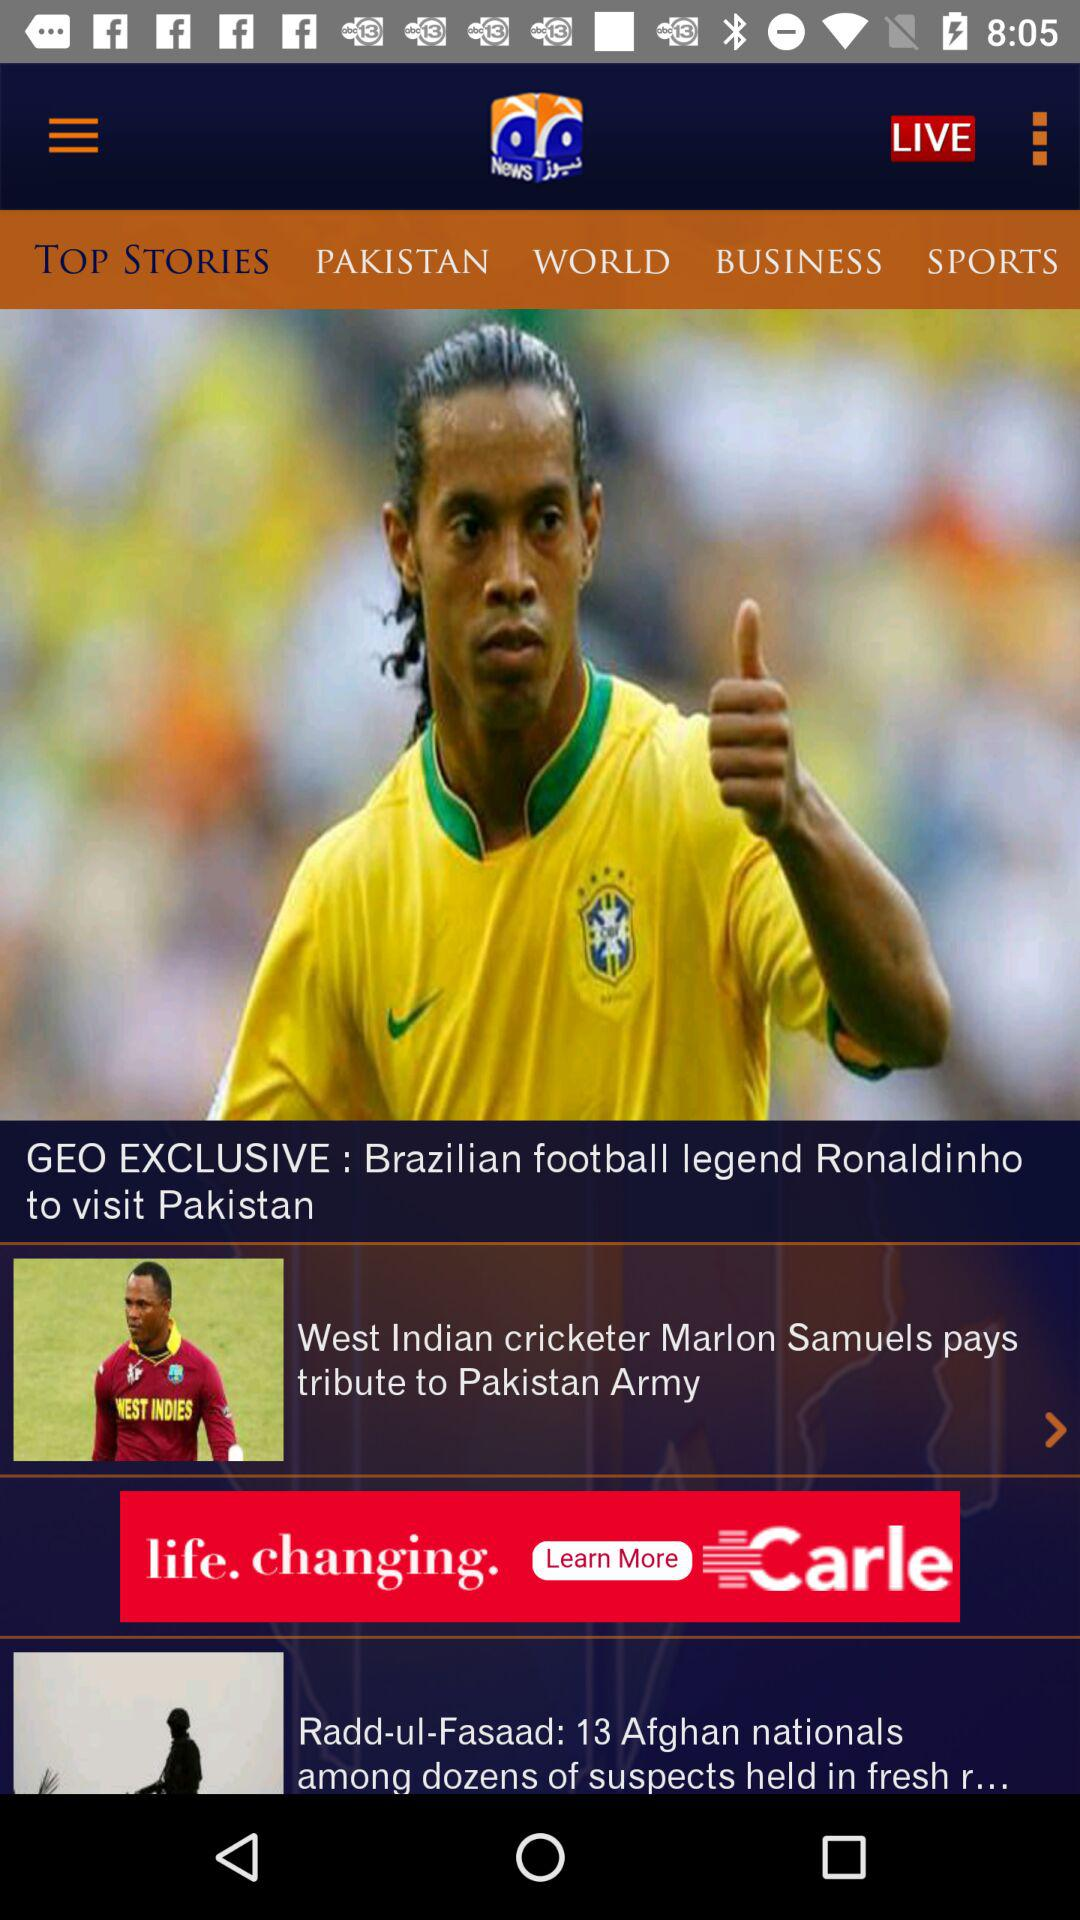What is the title of the news story? The titles are "GEO EXCLUSIVE : Brazilian football legend Ronaldinho to visit Pakistan", "West Indian cricketer Marlon Samuels pays tribute to Pakistan Army" and "Radd-ul-Fasaad: 13 Afghan nationals among dozens of suspects held in fresh r...". 